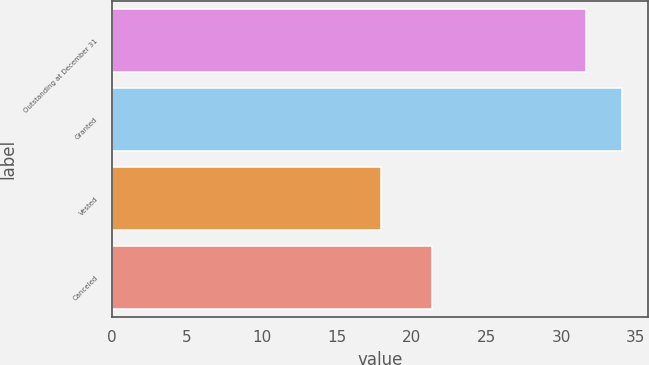<chart> <loc_0><loc_0><loc_500><loc_500><bar_chart><fcel>Outstanding at December 31<fcel>Granted<fcel>Vested<fcel>Canceled<nl><fcel>31.65<fcel>34.08<fcel>17.97<fcel>21.37<nl></chart> 